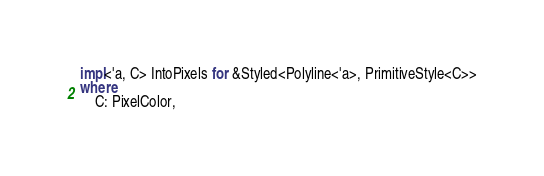<code> <loc_0><loc_0><loc_500><loc_500><_Rust_>impl<'a, C> IntoPixels for &Styled<Polyline<'a>, PrimitiveStyle<C>>
where
    C: PixelColor,</code> 